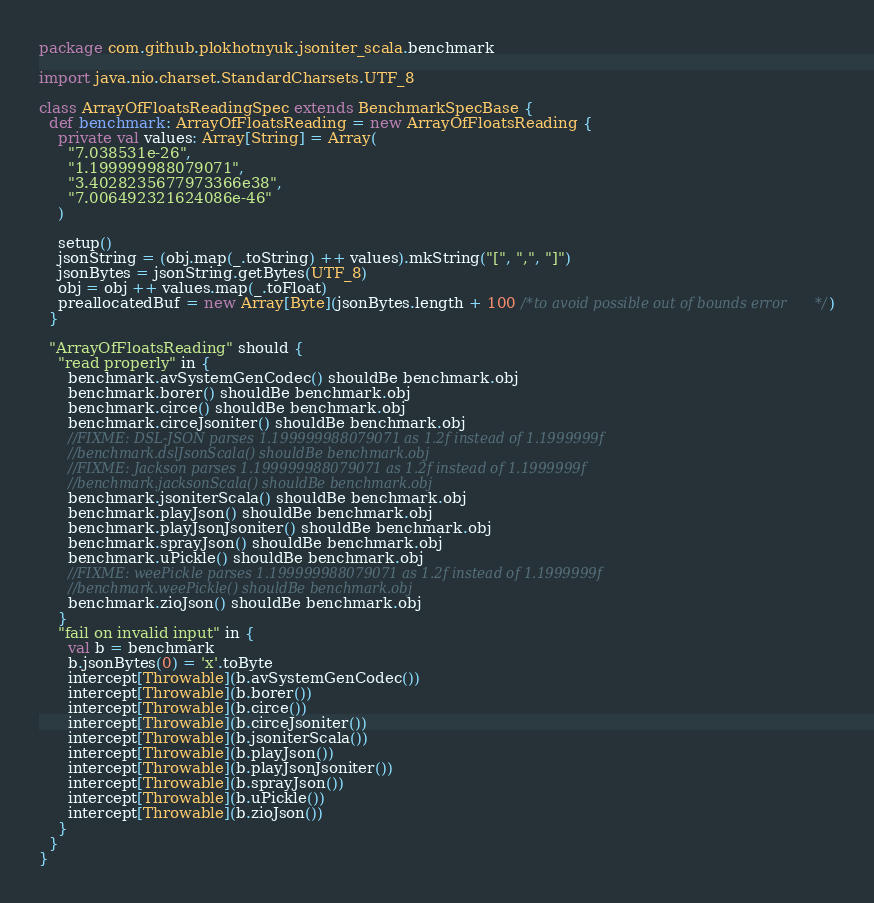Convert code to text. <code><loc_0><loc_0><loc_500><loc_500><_Scala_>package com.github.plokhotnyuk.jsoniter_scala.benchmark

import java.nio.charset.StandardCharsets.UTF_8

class ArrayOfFloatsReadingSpec extends BenchmarkSpecBase {
  def benchmark: ArrayOfFloatsReading = new ArrayOfFloatsReading {
    private val values: Array[String] = Array(
      "7.038531e-26",
      "1.199999988079071",
      "3.4028235677973366e38",
      "7.006492321624086e-46"
    )

    setup()
    jsonString = (obj.map(_.toString) ++ values).mkString("[", ",", "]")
    jsonBytes = jsonString.getBytes(UTF_8)
    obj = obj ++ values.map(_.toFloat)
    preallocatedBuf = new Array[Byte](jsonBytes.length + 100 /*to avoid possible out of bounds error*/)
  }

  "ArrayOfFloatsReading" should {
    "read properly" in {
      benchmark.avSystemGenCodec() shouldBe benchmark.obj
      benchmark.borer() shouldBe benchmark.obj
      benchmark.circe() shouldBe benchmark.obj
      benchmark.circeJsoniter() shouldBe benchmark.obj
      //FIXME: DSL-JSON parses 1.199999988079071 as 1.2f instead of 1.1999999f
      //benchmark.dslJsonScala() shouldBe benchmark.obj
      //FIXME: Jackson parses 1.199999988079071 as 1.2f instead of 1.1999999f
      //benchmark.jacksonScala() shouldBe benchmark.obj
      benchmark.jsoniterScala() shouldBe benchmark.obj
      benchmark.playJson() shouldBe benchmark.obj
      benchmark.playJsonJsoniter() shouldBe benchmark.obj
      benchmark.sprayJson() shouldBe benchmark.obj
      benchmark.uPickle() shouldBe benchmark.obj
      //FIXME: weePickle parses 1.199999988079071 as 1.2f instead of 1.1999999f
      //benchmark.weePickle() shouldBe benchmark.obj
      benchmark.zioJson() shouldBe benchmark.obj
    }
    "fail on invalid input" in {
      val b = benchmark
      b.jsonBytes(0) = 'x'.toByte
      intercept[Throwable](b.avSystemGenCodec())
      intercept[Throwable](b.borer())
      intercept[Throwable](b.circe())
      intercept[Throwable](b.circeJsoniter())
      intercept[Throwable](b.jsoniterScala())
      intercept[Throwable](b.playJson())
      intercept[Throwable](b.playJsonJsoniter())
      intercept[Throwable](b.sprayJson())
      intercept[Throwable](b.uPickle())
      intercept[Throwable](b.zioJson())
    }
  }
}</code> 